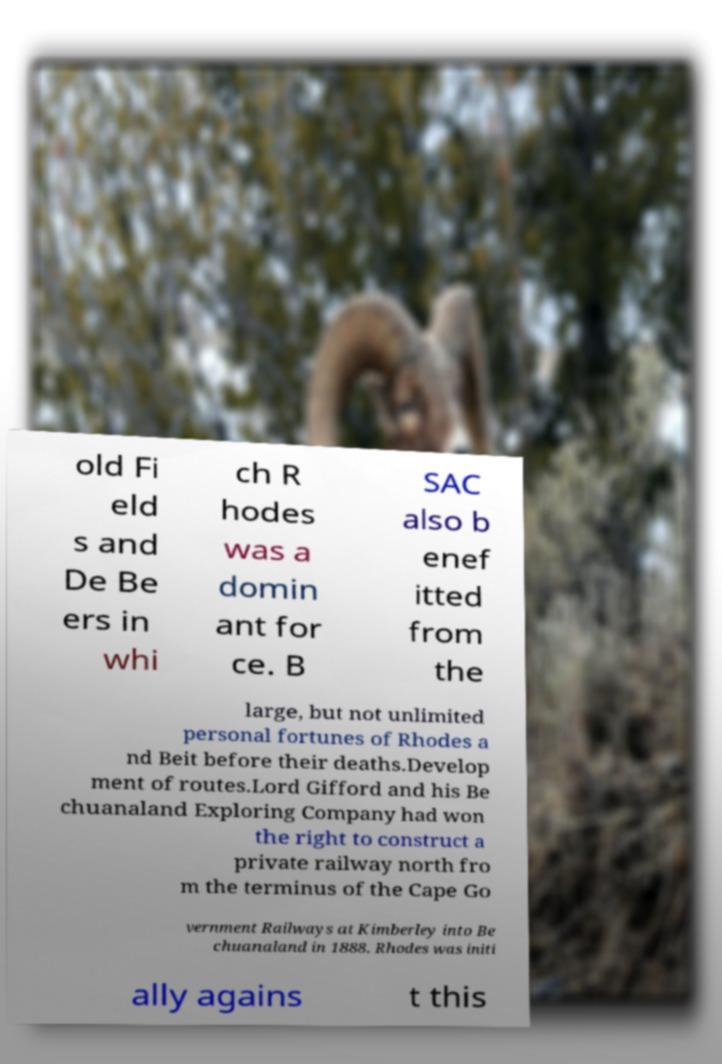Could you assist in decoding the text presented in this image and type it out clearly? old Fi eld s and De Be ers in whi ch R hodes was a domin ant for ce. B SAC also b enef itted from the large, but not unlimited personal fortunes of Rhodes a nd Beit before their deaths.Develop ment of routes.Lord Gifford and his Be chuanaland Exploring Company had won the right to construct a private railway north fro m the terminus of the Cape Go vernment Railways at Kimberley into Be chuanaland in 1888. Rhodes was initi ally agains t this 